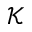<formula> <loc_0><loc_0><loc_500><loc_500>\mathcal { K }</formula> 